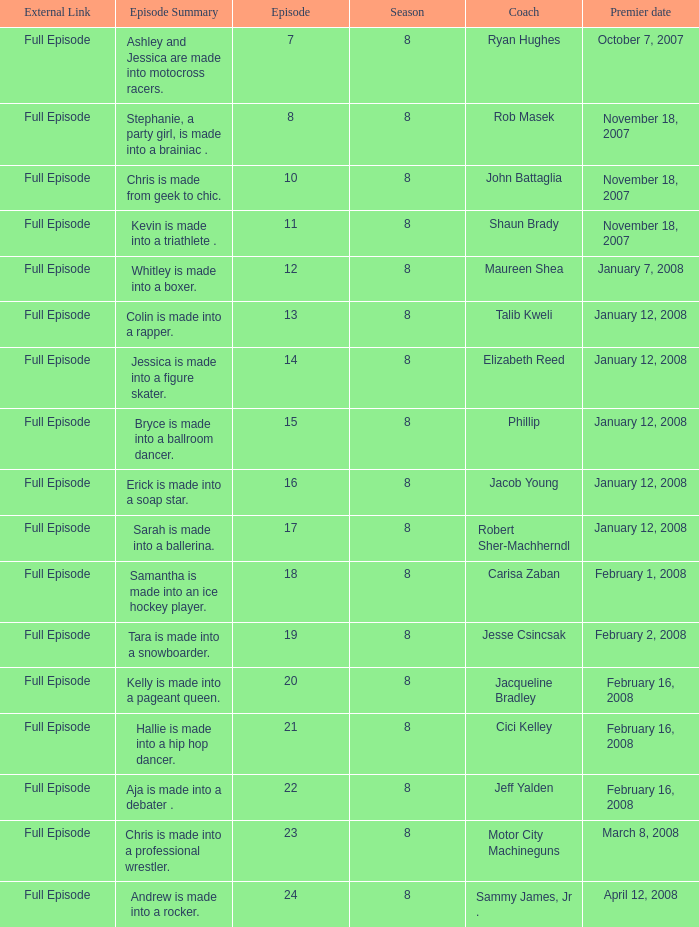Which episode of maximum had its premiere on march 8, 2008? 23.0. 